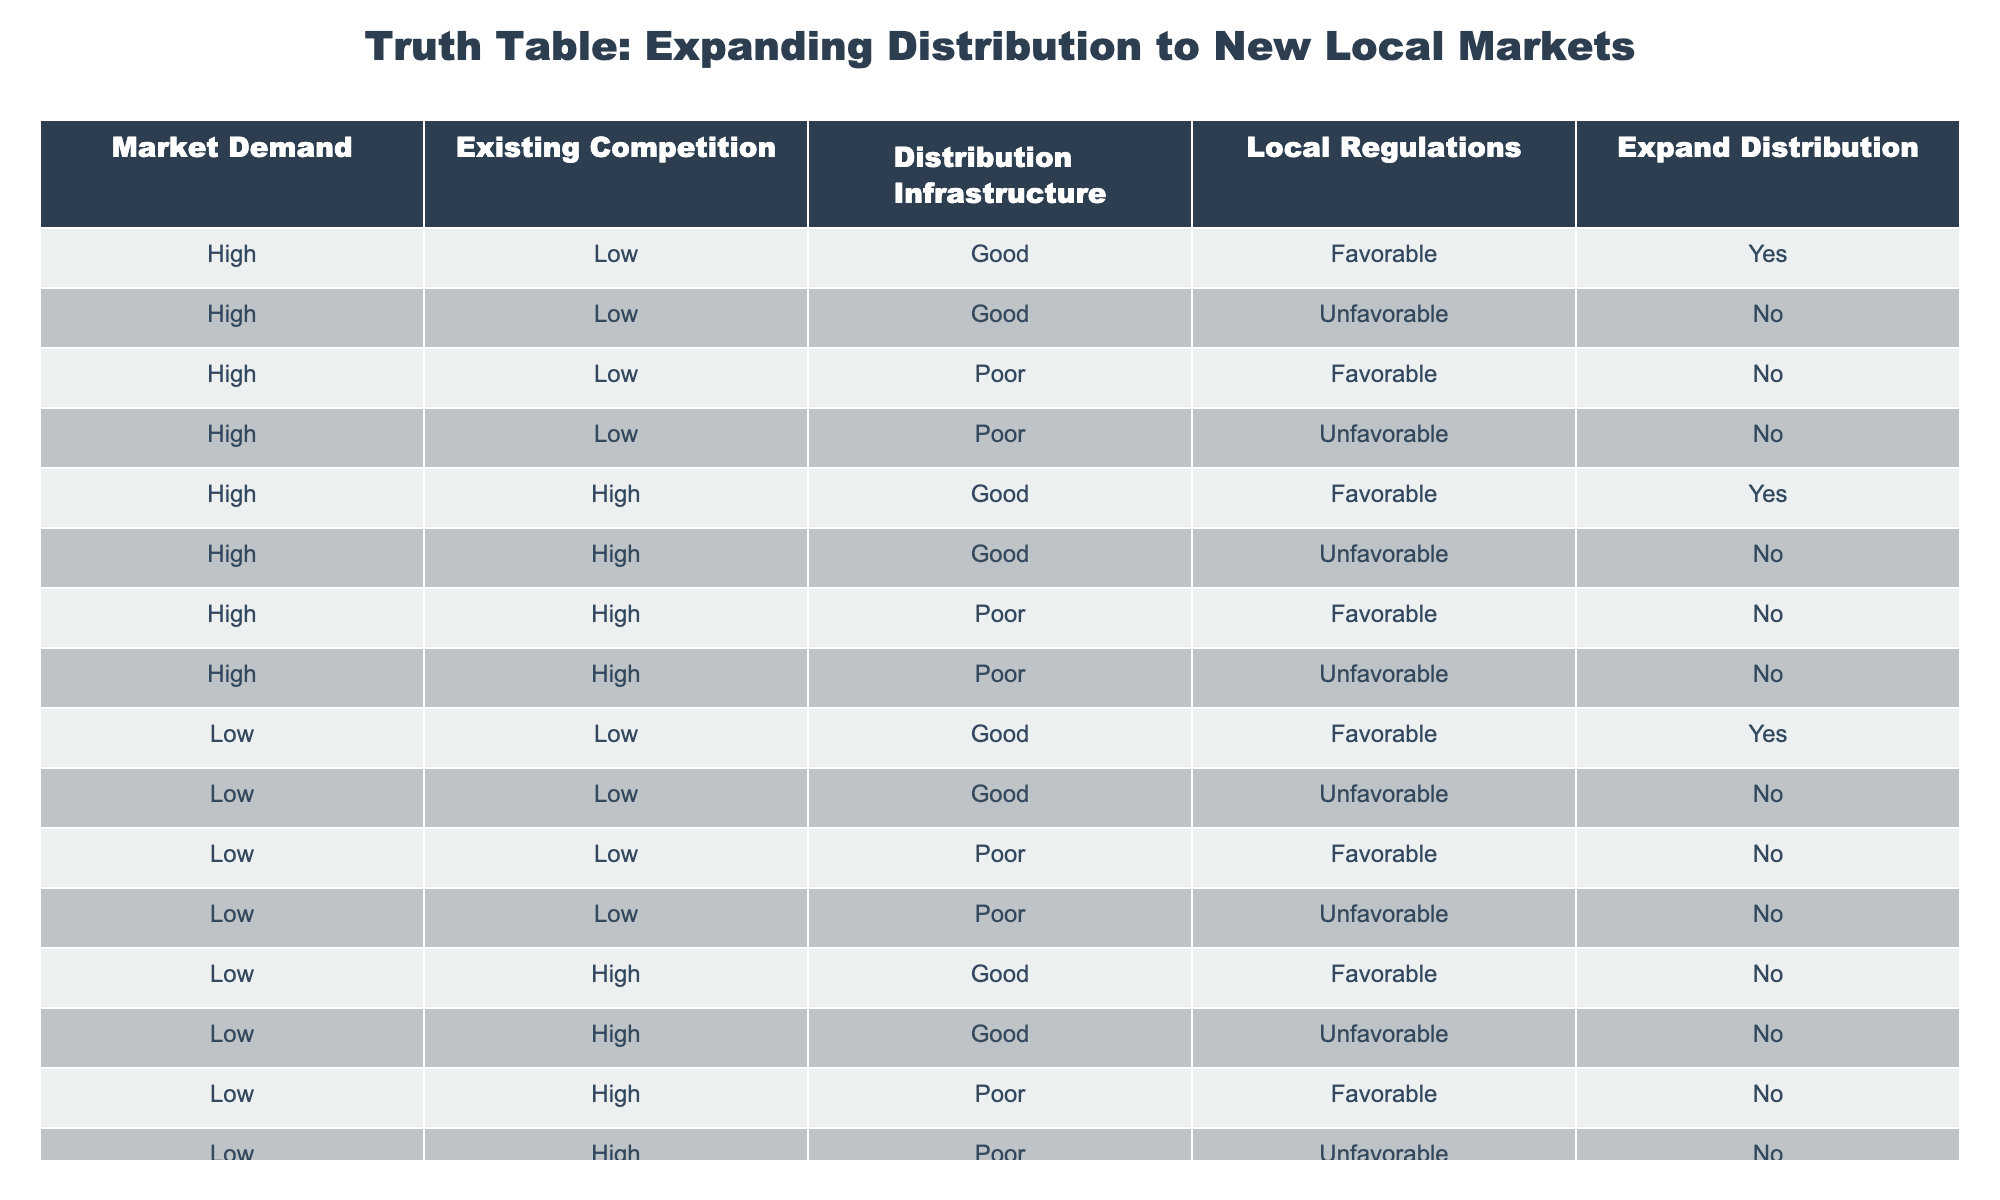What percentage of markets with high demand and favorable regulations are suitable for expansion? There are 3 entries with high demand and favorable regulations: 1) existing competition is low and infrastructure is good, 2) existing competition is high and infrastructure is good. Total entries are 8 for high demand. Therefore, the percentage is (2/8) * 100 = 25%.
Answer: 25% How many markets have low demand but good distribution infrastructure? There are 4 entries with low demand and good distribution infrastructure: 1) competition low and favorable regulations, 2) competition low and unfavorable regulations, 3) competition high and favorable regulations, 4) competition high and unfavorable regulations.
Answer: 4 Is it possible to expand distribution in a market with high demand, high competition, poor infrastructure, and unfavorable regulations? Based on the table, there is one entry that matches these conditions, and the expansion decision for that market is "No."
Answer: No What is the total number of markets where expanding distribution is allowed? By counting all entries marked "Yes," which are: (1) high demand, low competition, good infrastructure, favorable regulations; (2) high demand, high competition, good infrastructure, favorable regulations; (3) low demand, low competition, good infrastructure, favorable regulations. This gives us a total of 3 markets.
Answer: 3 For markets with high demand, how many have favorable regulations and are unsuitable for expansion? There are 4 entries with high demand and unfavorable regulations: 1) low competition, good infrastructure; 2) low competition, poor infrastructure; 3) high competition, good infrastructure; 4) high competition, poor infrastructure. Thus, the total is 4.
Answer: 4 In how many scenarios can expansion be pursued in markets with low demand? There are 2 entries for low demand where expansion can be pursued: both with good infrastructure and favorable regulations.
Answer: 2 What ratio of markets with high demand and poor infrastructure is found unsuitable for expansion? There are 4 entries with high demand and poor infrastructure, and all of them are marked "No" for expansion. The ratio of unsuitable to total entries is 4:4, simplifying to 1:1.
Answer: 1:1 How many total markets have been considered for expansion decisions? By counting all entries in the table, there are 16 total markets listed for decision-making regarding expansion.
Answer: 16 